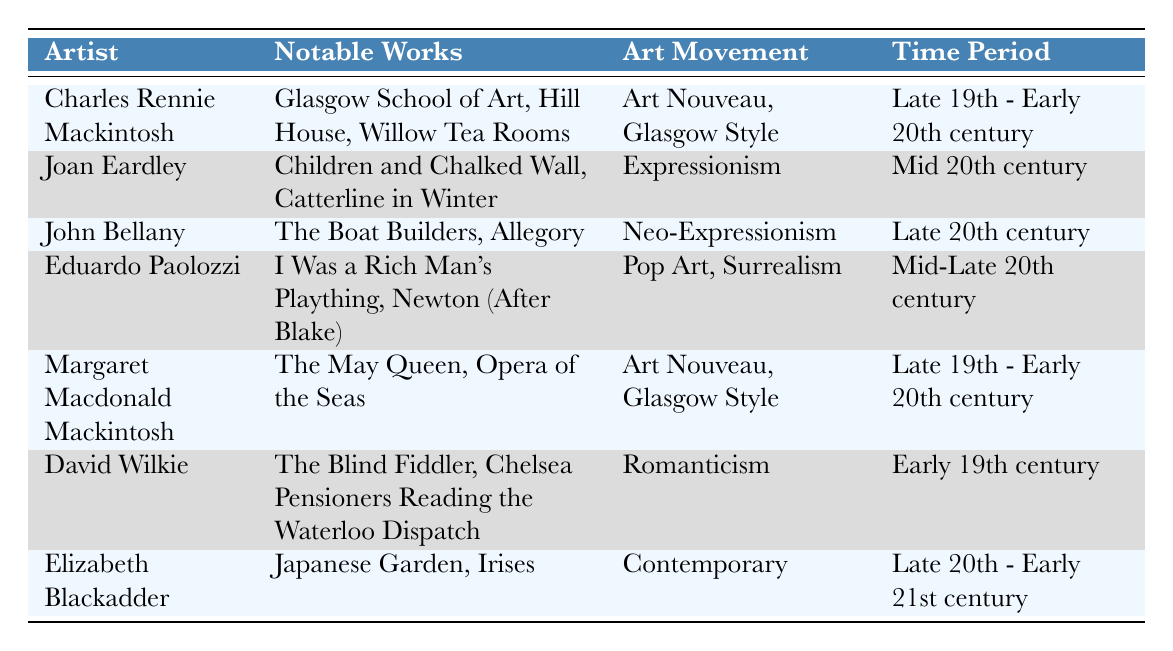What art movements are represented by Charles Rennie Mackintosh? Charles Rennie Mackintosh is listed under the "Art Movement" column with the entry "Art Nouveau, Glasgow Style."
Answer: Art Nouveau, Glasgow Style Which artist's notable works include "Japanese Garden"? The "Notable Works" section shows "Japanese Garden" is included in the entry for Elizabeth Blackadder.
Answer: Elizabeth Blackadder Is Joan Eardley associated with the late 19th century? Joan Eardley appears in the "Time Period" column with "Mid 20th century", which does not include the late 19th century.
Answer: No How many artists are categorized under the "Art Nouveau" movement? Both Charles Rennie Mackintosh and Margaret Macdonald Mackintosh are listed under "Art Nouveau, Glasgow Style," giving a total of two artists.
Answer: 2 Which artist has works that belong to the Romanticism movement, and what are the titles of those works? The artwork associated with David Wilkie in the "Notable Works" section includes "The Blind Fiddler" and "Chelsea Pensioners Reading the Waterloo Dispatch."
Answer: David Wilkie: The Blind Fiddler, Chelsea Pensioners Reading the Waterloo Dispatch What is the earliest time period represented in the table? The earliest period listed is "Early 19th century," associated with David Wilkie in the "Time Period" column.
Answer: Early 19th century Between which two time periods does Eduardo Paolozzi's work fall? The table indicates that Eduardo Paolozzi's works are from "Mid-Late 20th century," indicating a range between those years.
Answer: Mid-Late 20th century Are there any artists listed under the Contemporary movement? The table contains Elizabeth Blackadder under the "Art Movement" column as "Contemporary."
Answer: Yes Identify the artist associated with Neo-Expressionism and provide one of their notable works. John Bellany is identified in the table under "Art Movement" as Neo-Expressionism; one notable work listed is "The Boat Builders."
Answer: John Bellany: The Boat Builders 